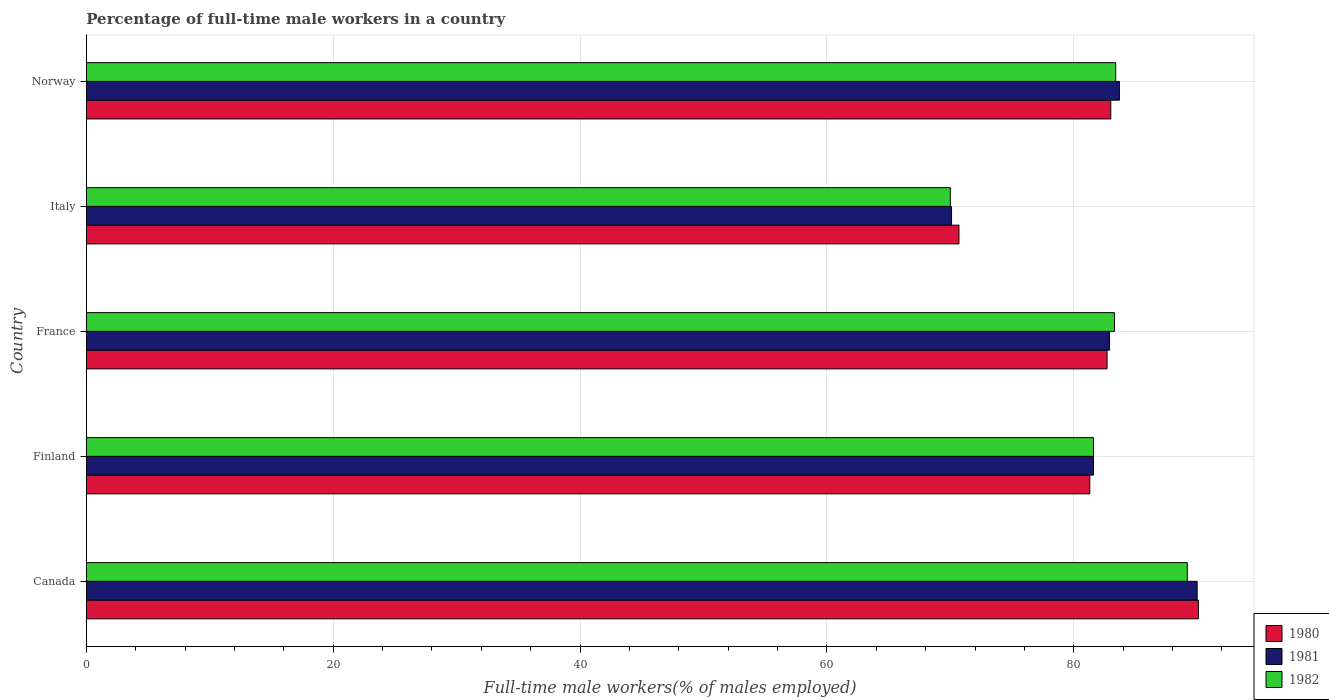Are the number of bars per tick equal to the number of legend labels?
Provide a short and direct response. Yes. Are the number of bars on each tick of the Y-axis equal?
Your answer should be very brief. Yes. How many bars are there on the 2nd tick from the top?
Provide a succinct answer. 3. In how many cases, is the number of bars for a given country not equal to the number of legend labels?
Provide a short and direct response. 0. What is the percentage of full-time male workers in 1982 in Norway?
Your response must be concise. 83.4. Across all countries, what is the maximum percentage of full-time male workers in 1980?
Ensure brevity in your answer.  90.1. Across all countries, what is the minimum percentage of full-time male workers in 1981?
Keep it short and to the point. 70.1. In which country was the percentage of full-time male workers in 1981 maximum?
Offer a very short reply. Canada. What is the total percentage of full-time male workers in 1980 in the graph?
Your answer should be compact. 407.8. What is the difference between the percentage of full-time male workers in 1981 in Canada and that in Finland?
Your response must be concise. 8.4. What is the difference between the percentage of full-time male workers in 1981 in Norway and the percentage of full-time male workers in 1982 in Finland?
Your response must be concise. 2.1. What is the average percentage of full-time male workers in 1982 per country?
Make the answer very short. 81.5. What is the difference between the percentage of full-time male workers in 1981 and percentage of full-time male workers in 1980 in Italy?
Provide a short and direct response. -0.6. In how many countries, is the percentage of full-time male workers in 1981 greater than 36 %?
Give a very brief answer. 5. What is the ratio of the percentage of full-time male workers in 1981 in Finland to that in Norway?
Make the answer very short. 0.97. Is the difference between the percentage of full-time male workers in 1981 in Canada and France greater than the difference between the percentage of full-time male workers in 1980 in Canada and France?
Your answer should be compact. No. What is the difference between the highest and the second highest percentage of full-time male workers in 1982?
Keep it short and to the point. 5.8. What is the difference between the highest and the lowest percentage of full-time male workers in 1981?
Give a very brief answer. 19.9. In how many countries, is the percentage of full-time male workers in 1982 greater than the average percentage of full-time male workers in 1982 taken over all countries?
Provide a short and direct response. 4. Is the sum of the percentage of full-time male workers in 1981 in Finland and Italy greater than the maximum percentage of full-time male workers in 1982 across all countries?
Keep it short and to the point. Yes. What is the difference between two consecutive major ticks on the X-axis?
Your answer should be compact. 20. Are the values on the major ticks of X-axis written in scientific E-notation?
Offer a very short reply. No. Does the graph contain grids?
Keep it short and to the point. Yes. Where does the legend appear in the graph?
Give a very brief answer. Bottom right. How many legend labels are there?
Provide a succinct answer. 3. How are the legend labels stacked?
Ensure brevity in your answer.  Vertical. What is the title of the graph?
Offer a terse response. Percentage of full-time male workers in a country. What is the label or title of the X-axis?
Provide a succinct answer. Full-time male workers(% of males employed). What is the label or title of the Y-axis?
Ensure brevity in your answer.  Country. What is the Full-time male workers(% of males employed) in 1980 in Canada?
Make the answer very short. 90.1. What is the Full-time male workers(% of males employed) in 1982 in Canada?
Your answer should be very brief. 89.2. What is the Full-time male workers(% of males employed) in 1980 in Finland?
Make the answer very short. 81.3. What is the Full-time male workers(% of males employed) of 1981 in Finland?
Provide a succinct answer. 81.6. What is the Full-time male workers(% of males employed) of 1982 in Finland?
Make the answer very short. 81.6. What is the Full-time male workers(% of males employed) of 1980 in France?
Offer a terse response. 82.7. What is the Full-time male workers(% of males employed) of 1981 in France?
Provide a short and direct response. 82.9. What is the Full-time male workers(% of males employed) in 1982 in France?
Your response must be concise. 83.3. What is the Full-time male workers(% of males employed) in 1980 in Italy?
Keep it short and to the point. 70.7. What is the Full-time male workers(% of males employed) of 1981 in Italy?
Provide a succinct answer. 70.1. What is the Full-time male workers(% of males employed) of 1982 in Italy?
Ensure brevity in your answer.  70. What is the Full-time male workers(% of males employed) of 1981 in Norway?
Your response must be concise. 83.7. What is the Full-time male workers(% of males employed) in 1982 in Norway?
Give a very brief answer. 83.4. Across all countries, what is the maximum Full-time male workers(% of males employed) in 1980?
Offer a very short reply. 90.1. Across all countries, what is the maximum Full-time male workers(% of males employed) of 1982?
Offer a very short reply. 89.2. Across all countries, what is the minimum Full-time male workers(% of males employed) in 1980?
Provide a succinct answer. 70.7. Across all countries, what is the minimum Full-time male workers(% of males employed) of 1981?
Offer a terse response. 70.1. Across all countries, what is the minimum Full-time male workers(% of males employed) of 1982?
Provide a succinct answer. 70. What is the total Full-time male workers(% of males employed) of 1980 in the graph?
Provide a short and direct response. 407.8. What is the total Full-time male workers(% of males employed) of 1981 in the graph?
Offer a very short reply. 408.3. What is the total Full-time male workers(% of males employed) of 1982 in the graph?
Offer a terse response. 407.5. What is the difference between the Full-time male workers(% of males employed) in 1982 in Canada and that in Finland?
Make the answer very short. 7.6. What is the difference between the Full-time male workers(% of males employed) in 1980 in Canada and that in France?
Your answer should be very brief. 7.4. What is the difference between the Full-time male workers(% of males employed) of 1980 in Canada and that in Italy?
Provide a short and direct response. 19.4. What is the difference between the Full-time male workers(% of males employed) of 1981 in Canada and that in Italy?
Provide a succinct answer. 19.9. What is the difference between the Full-time male workers(% of males employed) of 1980 in Canada and that in Norway?
Your answer should be very brief. 7.1. What is the difference between the Full-time male workers(% of males employed) in 1981 in Canada and that in Norway?
Offer a very short reply. 6.3. What is the difference between the Full-time male workers(% of males employed) of 1982 in Canada and that in Norway?
Your response must be concise. 5.8. What is the difference between the Full-time male workers(% of males employed) in 1981 in Finland and that in France?
Provide a succinct answer. -1.3. What is the difference between the Full-time male workers(% of males employed) of 1982 in Finland and that in France?
Provide a succinct answer. -1.7. What is the difference between the Full-time male workers(% of males employed) in 1981 in Finland and that in Italy?
Keep it short and to the point. 11.5. What is the difference between the Full-time male workers(% of males employed) of 1982 in Finland and that in Norway?
Make the answer very short. -1.8. What is the difference between the Full-time male workers(% of males employed) in 1982 in Italy and that in Norway?
Ensure brevity in your answer.  -13.4. What is the difference between the Full-time male workers(% of males employed) in 1980 in Canada and the Full-time male workers(% of males employed) in 1981 in Finland?
Provide a succinct answer. 8.5. What is the difference between the Full-time male workers(% of males employed) in 1980 in Canada and the Full-time male workers(% of males employed) in 1982 in Finland?
Offer a terse response. 8.5. What is the difference between the Full-time male workers(% of males employed) of 1980 in Canada and the Full-time male workers(% of males employed) of 1982 in France?
Your answer should be compact. 6.8. What is the difference between the Full-time male workers(% of males employed) of 1980 in Canada and the Full-time male workers(% of males employed) of 1982 in Italy?
Your answer should be compact. 20.1. What is the difference between the Full-time male workers(% of males employed) in 1980 in Canada and the Full-time male workers(% of males employed) in 1982 in Norway?
Your answer should be very brief. 6.7. What is the difference between the Full-time male workers(% of males employed) of 1981 in Canada and the Full-time male workers(% of males employed) of 1982 in Norway?
Give a very brief answer. 6.6. What is the difference between the Full-time male workers(% of males employed) in 1981 in Finland and the Full-time male workers(% of males employed) in 1982 in France?
Ensure brevity in your answer.  -1.7. What is the difference between the Full-time male workers(% of males employed) in 1981 in Finland and the Full-time male workers(% of males employed) in 1982 in Norway?
Provide a succinct answer. -1.8. What is the difference between the Full-time male workers(% of males employed) in 1980 in France and the Full-time male workers(% of males employed) in 1981 in Norway?
Offer a very short reply. -1. What is the difference between the Full-time male workers(% of males employed) in 1981 in France and the Full-time male workers(% of males employed) in 1982 in Norway?
Give a very brief answer. -0.5. What is the difference between the Full-time male workers(% of males employed) of 1980 in Italy and the Full-time male workers(% of males employed) of 1982 in Norway?
Your answer should be very brief. -12.7. What is the average Full-time male workers(% of males employed) in 1980 per country?
Your response must be concise. 81.56. What is the average Full-time male workers(% of males employed) in 1981 per country?
Ensure brevity in your answer.  81.66. What is the average Full-time male workers(% of males employed) in 1982 per country?
Your answer should be very brief. 81.5. What is the difference between the Full-time male workers(% of males employed) of 1981 and Full-time male workers(% of males employed) of 1982 in Canada?
Offer a terse response. 0.8. What is the difference between the Full-time male workers(% of males employed) in 1981 and Full-time male workers(% of males employed) in 1982 in Finland?
Offer a terse response. 0. What is the difference between the Full-time male workers(% of males employed) in 1980 and Full-time male workers(% of males employed) in 1982 in France?
Offer a very short reply. -0.6. What is the difference between the Full-time male workers(% of males employed) of 1981 and Full-time male workers(% of males employed) of 1982 in Italy?
Your answer should be compact. 0.1. What is the ratio of the Full-time male workers(% of males employed) of 1980 in Canada to that in Finland?
Ensure brevity in your answer.  1.11. What is the ratio of the Full-time male workers(% of males employed) of 1981 in Canada to that in Finland?
Your answer should be very brief. 1.1. What is the ratio of the Full-time male workers(% of males employed) in 1982 in Canada to that in Finland?
Your answer should be compact. 1.09. What is the ratio of the Full-time male workers(% of males employed) of 1980 in Canada to that in France?
Provide a succinct answer. 1.09. What is the ratio of the Full-time male workers(% of males employed) of 1981 in Canada to that in France?
Provide a succinct answer. 1.09. What is the ratio of the Full-time male workers(% of males employed) of 1982 in Canada to that in France?
Provide a succinct answer. 1.07. What is the ratio of the Full-time male workers(% of males employed) of 1980 in Canada to that in Italy?
Your response must be concise. 1.27. What is the ratio of the Full-time male workers(% of males employed) in 1981 in Canada to that in Italy?
Provide a succinct answer. 1.28. What is the ratio of the Full-time male workers(% of males employed) of 1982 in Canada to that in Italy?
Keep it short and to the point. 1.27. What is the ratio of the Full-time male workers(% of males employed) in 1980 in Canada to that in Norway?
Offer a very short reply. 1.09. What is the ratio of the Full-time male workers(% of males employed) of 1981 in Canada to that in Norway?
Your answer should be very brief. 1.08. What is the ratio of the Full-time male workers(% of males employed) in 1982 in Canada to that in Norway?
Make the answer very short. 1.07. What is the ratio of the Full-time male workers(% of males employed) in 1980 in Finland to that in France?
Keep it short and to the point. 0.98. What is the ratio of the Full-time male workers(% of males employed) of 1981 in Finland to that in France?
Your answer should be very brief. 0.98. What is the ratio of the Full-time male workers(% of males employed) in 1982 in Finland to that in France?
Your answer should be very brief. 0.98. What is the ratio of the Full-time male workers(% of males employed) in 1980 in Finland to that in Italy?
Offer a terse response. 1.15. What is the ratio of the Full-time male workers(% of males employed) in 1981 in Finland to that in Italy?
Ensure brevity in your answer.  1.16. What is the ratio of the Full-time male workers(% of males employed) of 1982 in Finland to that in Italy?
Make the answer very short. 1.17. What is the ratio of the Full-time male workers(% of males employed) of 1980 in Finland to that in Norway?
Your answer should be compact. 0.98. What is the ratio of the Full-time male workers(% of males employed) of 1981 in Finland to that in Norway?
Provide a short and direct response. 0.97. What is the ratio of the Full-time male workers(% of males employed) in 1982 in Finland to that in Norway?
Provide a short and direct response. 0.98. What is the ratio of the Full-time male workers(% of males employed) of 1980 in France to that in Italy?
Keep it short and to the point. 1.17. What is the ratio of the Full-time male workers(% of males employed) in 1981 in France to that in Italy?
Offer a very short reply. 1.18. What is the ratio of the Full-time male workers(% of males employed) of 1982 in France to that in Italy?
Give a very brief answer. 1.19. What is the ratio of the Full-time male workers(% of males employed) in 1980 in France to that in Norway?
Your response must be concise. 1. What is the ratio of the Full-time male workers(% of males employed) in 1980 in Italy to that in Norway?
Your response must be concise. 0.85. What is the ratio of the Full-time male workers(% of males employed) in 1981 in Italy to that in Norway?
Give a very brief answer. 0.84. What is the ratio of the Full-time male workers(% of males employed) of 1982 in Italy to that in Norway?
Offer a very short reply. 0.84. What is the difference between the highest and the second highest Full-time male workers(% of males employed) of 1980?
Keep it short and to the point. 7.1. What is the difference between the highest and the second highest Full-time male workers(% of males employed) of 1982?
Your answer should be very brief. 5.8. What is the difference between the highest and the lowest Full-time male workers(% of males employed) in 1981?
Provide a succinct answer. 19.9. What is the difference between the highest and the lowest Full-time male workers(% of males employed) in 1982?
Your response must be concise. 19.2. 